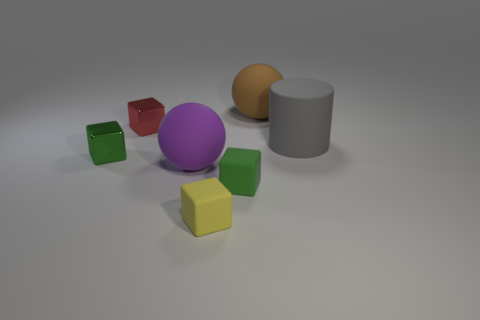Add 1 purple metallic cylinders. How many objects exist? 8 Subtract all balls. How many objects are left? 5 Add 5 large brown cubes. How many large brown cubes exist? 5 Subtract 0 blue cylinders. How many objects are left? 7 Subtract all balls. Subtract all large purple matte balls. How many objects are left? 4 Add 3 gray cylinders. How many gray cylinders are left? 4 